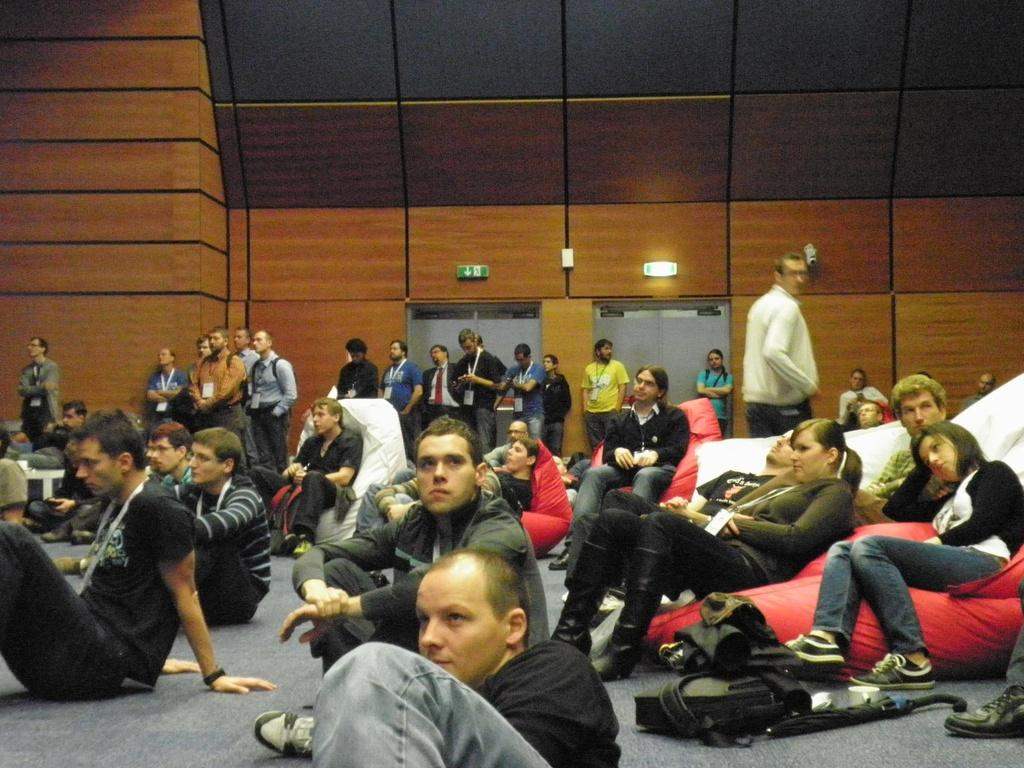How many people are in the image? There is a group of people in the image. What are some of the people in the image doing? Some people are sitting, and some people are standing. What can be seen in the background of the image? There is a wall, doors, and sign boards in the background of the image. What type of reaction can be seen on the birthday cake in the image? There is no birthday cake present in the image, so it is not possible to determine any reactions on it. 